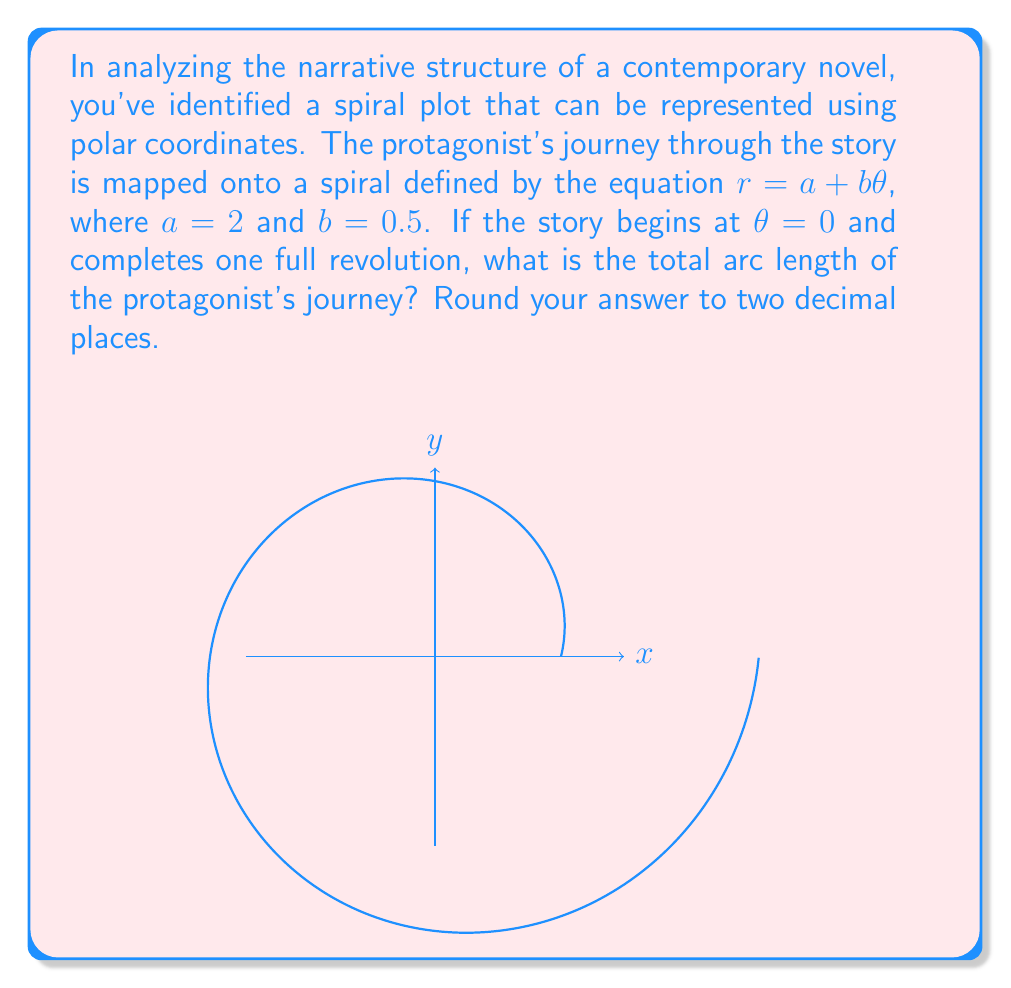Show me your answer to this math problem. To solve this problem, we'll follow these steps:

1) The arc length of a spiral in polar coordinates is given by the formula:

   $$L = \int_0^{2\pi} \sqrt{r^2 + (\frac{dr}{d\theta})^2} d\theta$$

2) For our spiral, $r = a + b\theta$, where $a = 2$ and $b = 0.5$. We need to find $\frac{dr}{d\theta}$:

   $$\frac{dr}{d\theta} = b = 0.5$$

3) Substituting these into the arc length formula:

   $$L = \int_0^{2\pi} \sqrt{(2 + 0.5\theta)^2 + 0.5^2} d\theta$$

4) Simplify under the square root:

   $$L = \int_0^{2\pi} \sqrt{4 + 2\theta + 0.25\theta^2 + 0.25} d\theta$$
   $$L = \int_0^{2\pi} \sqrt{4.25 + 2\theta + 0.25\theta^2} d\theta$$

5) This integral doesn't have an elementary antiderivative, so we need to use numerical integration. Using a computer algebra system or numerical integration tool, we get:

   $$L \approx 13.3619$$

6) Rounding to two decimal places:

   $$L \approx 13.36$$

This result represents the total arc length of the protagonist's journey through the narrative structure, mapped onto the spiral plot.
Answer: $13.36$ 